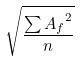<formula> <loc_0><loc_0><loc_500><loc_500>\sqrt { \frac { \sum { A _ { f } } ^ { 2 } } { n } }</formula> 